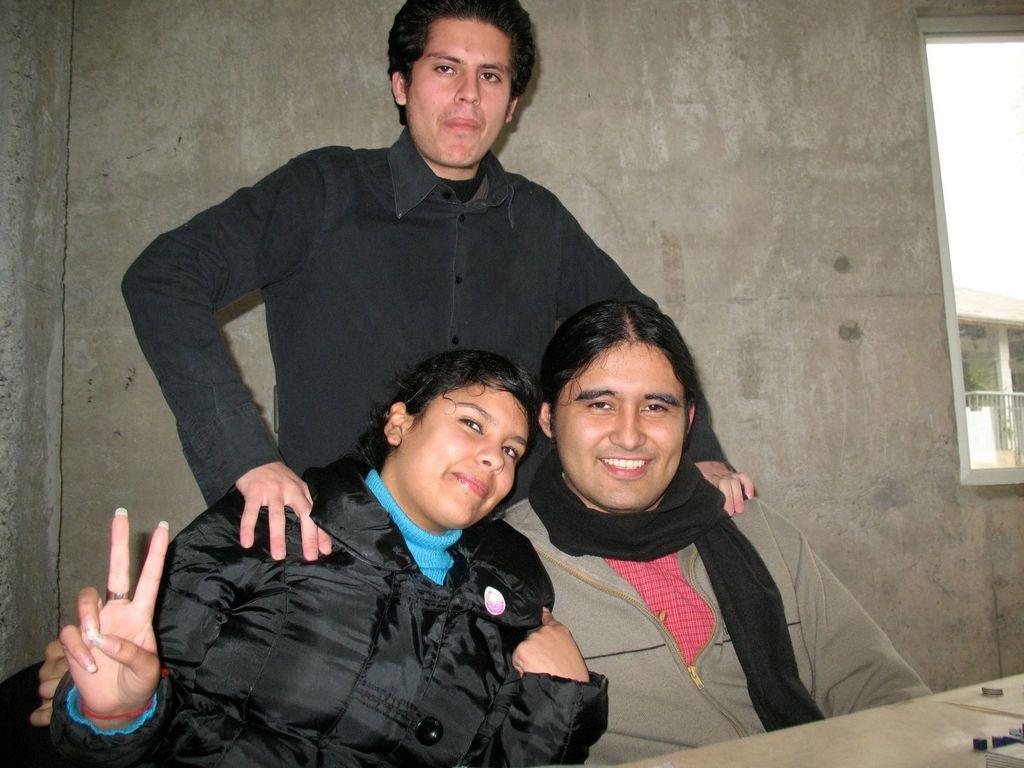Could you give a brief overview of what you see in this image? There are two people sitting and smiling, behind these two people there is a man standing. We can see objects on the table. In the background we can see wall and window, through this window we can see fence, pillar, rooftop and sky. 